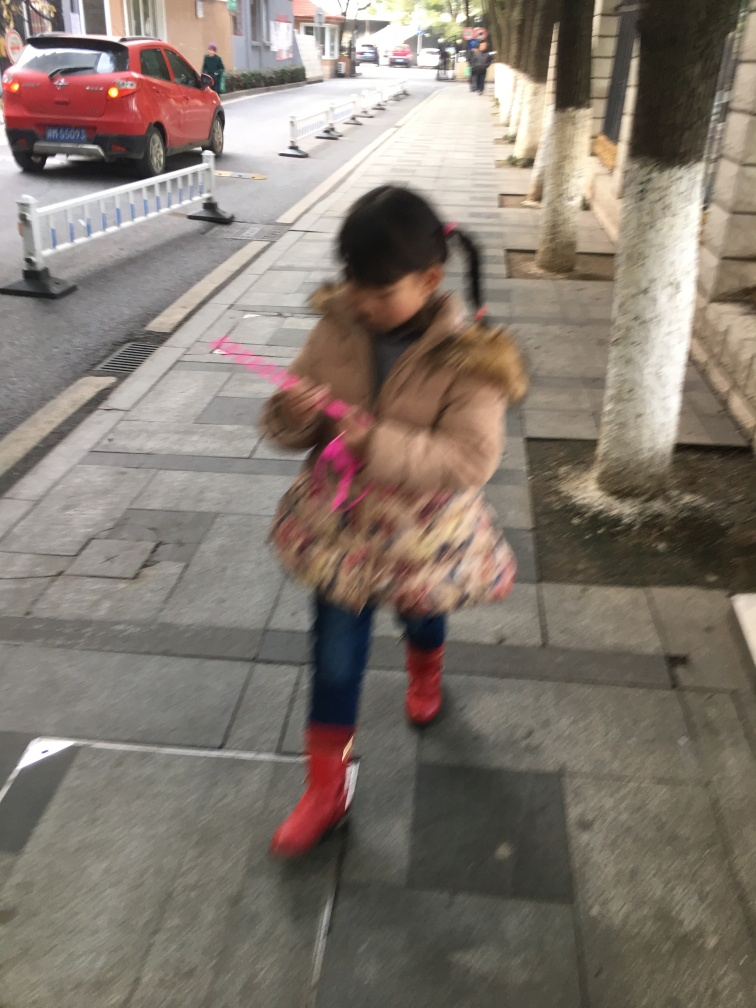Can you describe the person in this image? The person in the image appears to be a young girl. She's in mid-motion, suggesting that she may be walking or skipping. She has dark hair tied in pigtails and is wearing a brown coat with a colorful pattern, blue jeans, and red boots. Her pose and blurry appearance also convey a sense of movement and playfulness. What can you infer about the setting of the photo? The setting appears to be an outdoor urban environment, likely a sidewalk along a road. The presence of a car in the background, white bollards, and lined pavement indicate a structured and designed space for pedestrian and vehicular activity. The buildings in the background with architectural columns suggest this might be a location near businesses or residential areas with some classical design elements. 